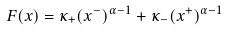<formula> <loc_0><loc_0><loc_500><loc_500>F ( x ) = \kappa _ { + } ( x ^ { - } ) ^ { \alpha - 1 } + \kappa _ { - } ( x ^ { + } ) ^ { \alpha - 1 }</formula> 